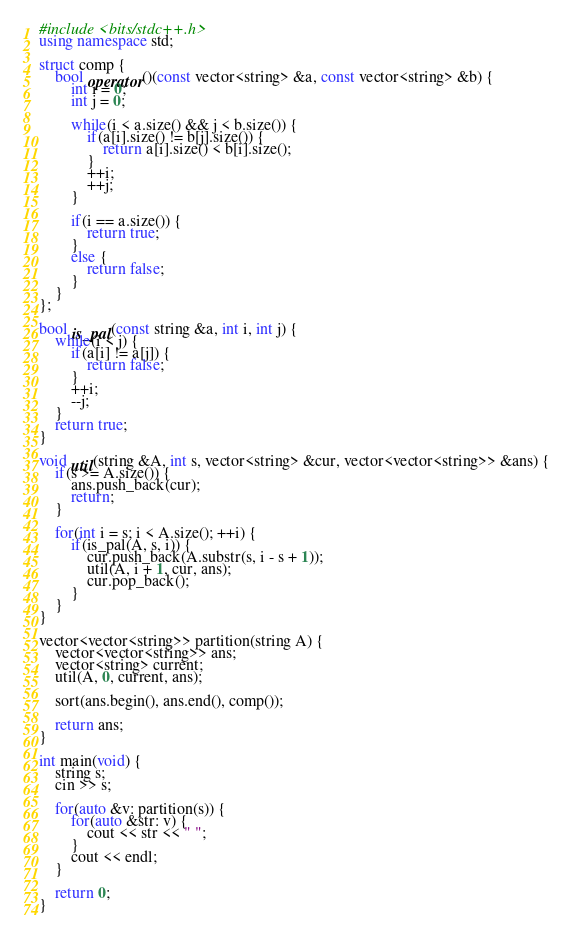<code> <loc_0><loc_0><loc_500><loc_500><_C++_>#include <bits/stdc++.h>
using namespace std;

struct comp {
	bool operator()(const vector<string> &a, const vector<string> &b) {
		int i = 0;
		int j = 0;

		while(i < a.size() && j < b.size()) {
			if(a[i].size() != b[j].size()) {
				return a[i].size() < b[i].size();
			}
			++i;
			++j;
		}

		if(i == a.size()) {
			return true;
		}
		else {
			return false;
		}
	}
};

bool is_pal(const string &a, int i, int j) {
	while(i < j) {
		if(a[i] != a[j]) {
			return false;
		}
		++i;
		--j;
	}
	return true;
}

void util(string &A, int s, vector<string> &cur, vector<vector<string>> &ans) {
	if(s >= A.size()) {
		ans.push_back(cur);
		return;
	}

	for(int i = s; i < A.size(); ++i) {
		if(is_pal(A, s, i)) {
			cur.push_back(A.substr(s, i - s + 1));
			util(A, i + 1, cur, ans);
			cur.pop_back();
		}
	}
}

vector<vector<string>> partition(string A) {
    vector<vector<string>> ans;
    vector<string> current;
    util(A, 0, current, ans);

    sort(ans.begin(), ans.end(), comp());

    return ans;
}

int main(void) {
	string s;
	cin >> s;

	for(auto &v: partition(s)) {
		for(auto &str: v) {
			cout << str << " ";
		}
		cout << endl;
	}

	return 0;
}</code> 